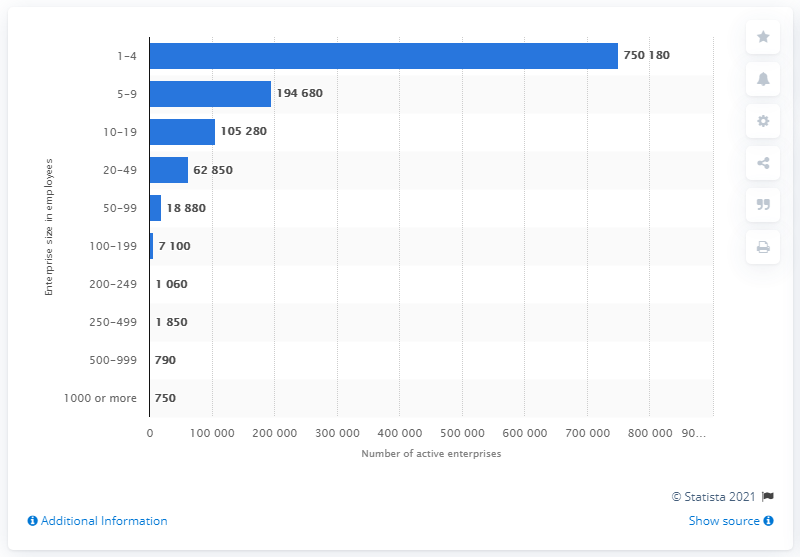List a handful of essential elements in this visual. There were 750 enterprises with more than 1,000 employees registered in Canada in 2013. 